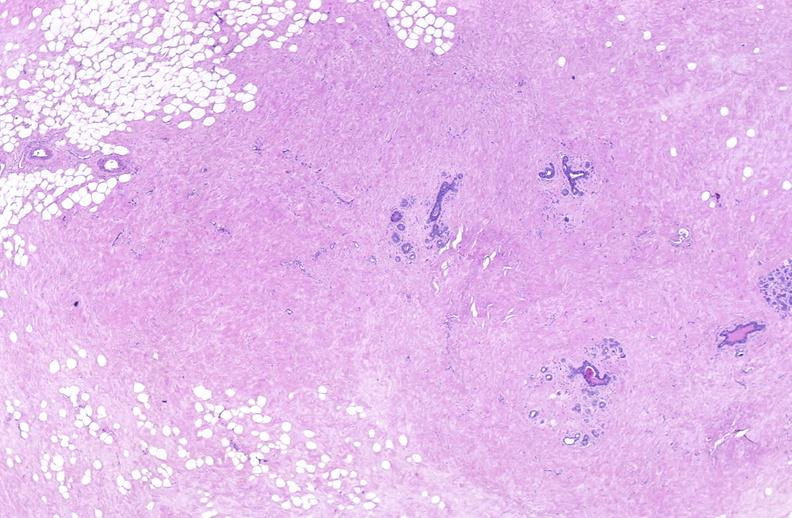does this image show breast, fibroadenoma?
Answer the question using a single word or phrase. Yes 